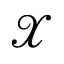Convert formula to latex. <formula><loc_0><loc_0><loc_500><loc_500>\mathcal { X }</formula> 